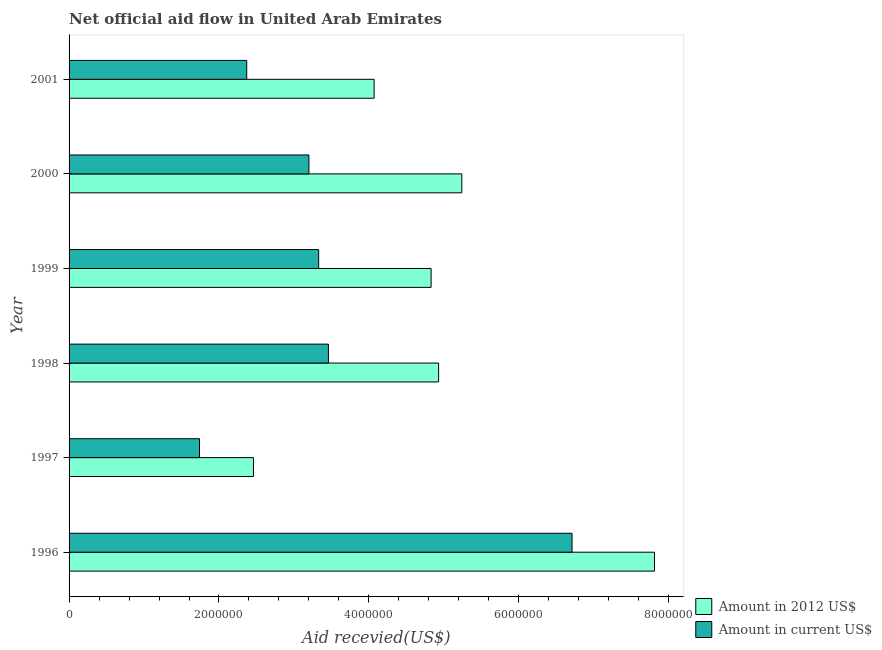How many different coloured bars are there?
Your answer should be compact. 2. How many groups of bars are there?
Your response must be concise. 6. Are the number of bars per tick equal to the number of legend labels?
Your answer should be very brief. Yes. Are the number of bars on each tick of the Y-axis equal?
Give a very brief answer. Yes. How many bars are there on the 3rd tick from the top?
Provide a short and direct response. 2. What is the amount of aid received(expressed in 2012 us$) in 1998?
Your response must be concise. 4.93e+06. Across all years, what is the maximum amount of aid received(expressed in us$)?
Make the answer very short. 6.71e+06. Across all years, what is the minimum amount of aid received(expressed in us$)?
Your answer should be very brief. 1.74e+06. In which year was the amount of aid received(expressed in us$) minimum?
Make the answer very short. 1997. What is the total amount of aid received(expressed in 2012 us$) in the graph?
Your response must be concise. 2.93e+07. What is the difference between the amount of aid received(expressed in us$) in 1999 and that in 2000?
Your answer should be compact. 1.30e+05. What is the difference between the amount of aid received(expressed in us$) in 2000 and the amount of aid received(expressed in 2012 us$) in 1997?
Your answer should be very brief. 7.40e+05. What is the average amount of aid received(expressed in us$) per year?
Make the answer very short. 3.47e+06. In the year 1996, what is the difference between the amount of aid received(expressed in us$) and amount of aid received(expressed in 2012 us$)?
Offer a terse response. -1.10e+06. What is the ratio of the amount of aid received(expressed in 2012 us$) in 1996 to that in 2001?
Provide a succinct answer. 1.92. Is the amount of aid received(expressed in 2012 us$) in 1997 less than that in 2000?
Your answer should be very brief. Yes. Is the difference between the amount of aid received(expressed in 2012 us$) in 1997 and 2000 greater than the difference between the amount of aid received(expressed in us$) in 1997 and 2000?
Keep it short and to the point. No. What is the difference between the highest and the second highest amount of aid received(expressed in us$)?
Provide a succinct answer. 3.25e+06. What is the difference between the highest and the lowest amount of aid received(expressed in us$)?
Your response must be concise. 4.97e+06. What does the 1st bar from the top in 2000 represents?
Give a very brief answer. Amount in current US$. What does the 2nd bar from the bottom in 2001 represents?
Keep it short and to the point. Amount in current US$. How many bars are there?
Provide a succinct answer. 12. How many years are there in the graph?
Your response must be concise. 6. Are the values on the major ticks of X-axis written in scientific E-notation?
Make the answer very short. No. Does the graph contain any zero values?
Offer a very short reply. No. Does the graph contain grids?
Your answer should be compact. No. How many legend labels are there?
Your answer should be very brief. 2. What is the title of the graph?
Offer a terse response. Net official aid flow in United Arab Emirates. Does "Male entrants" appear as one of the legend labels in the graph?
Keep it short and to the point. No. What is the label or title of the X-axis?
Offer a very short reply. Aid recevied(US$). What is the label or title of the Y-axis?
Your response must be concise. Year. What is the Aid recevied(US$) of Amount in 2012 US$ in 1996?
Your response must be concise. 7.81e+06. What is the Aid recevied(US$) in Amount in current US$ in 1996?
Ensure brevity in your answer.  6.71e+06. What is the Aid recevied(US$) in Amount in 2012 US$ in 1997?
Provide a succinct answer. 2.46e+06. What is the Aid recevied(US$) in Amount in current US$ in 1997?
Give a very brief answer. 1.74e+06. What is the Aid recevied(US$) of Amount in 2012 US$ in 1998?
Provide a short and direct response. 4.93e+06. What is the Aid recevied(US$) in Amount in current US$ in 1998?
Offer a terse response. 3.46e+06. What is the Aid recevied(US$) in Amount in 2012 US$ in 1999?
Keep it short and to the point. 4.83e+06. What is the Aid recevied(US$) in Amount in current US$ in 1999?
Your answer should be compact. 3.33e+06. What is the Aid recevied(US$) in Amount in 2012 US$ in 2000?
Offer a very short reply. 5.24e+06. What is the Aid recevied(US$) of Amount in current US$ in 2000?
Keep it short and to the point. 3.20e+06. What is the Aid recevied(US$) in Amount in 2012 US$ in 2001?
Keep it short and to the point. 4.07e+06. What is the Aid recevied(US$) of Amount in current US$ in 2001?
Ensure brevity in your answer.  2.37e+06. Across all years, what is the maximum Aid recevied(US$) in Amount in 2012 US$?
Ensure brevity in your answer.  7.81e+06. Across all years, what is the maximum Aid recevied(US$) of Amount in current US$?
Your answer should be compact. 6.71e+06. Across all years, what is the minimum Aid recevied(US$) in Amount in 2012 US$?
Keep it short and to the point. 2.46e+06. Across all years, what is the minimum Aid recevied(US$) of Amount in current US$?
Make the answer very short. 1.74e+06. What is the total Aid recevied(US$) in Amount in 2012 US$ in the graph?
Keep it short and to the point. 2.93e+07. What is the total Aid recevied(US$) of Amount in current US$ in the graph?
Your response must be concise. 2.08e+07. What is the difference between the Aid recevied(US$) of Amount in 2012 US$ in 1996 and that in 1997?
Provide a short and direct response. 5.35e+06. What is the difference between the Aid recevied(US$) of Amount in current US$ in 1996 and that in 1997?
Make the answer very short. 4.97e+06. What is the difference between the Aid recevied(US$) in Amount in 2012 US$ in 1996 and that in 1998?
Give a very brief answer. 2.88e+06. What is the difference between the Aid recevied(US$) of Amount in current US$ in 1996 and that in 1998?
Your response must be concise. 3.25e+06. What is the difference between the Aid recevied(US$) of Amount in 2012 US$ in 1996 and that in 1999?
Your response must be concise. 2.98e+06. What is the difference between the Aid recevied(US$) in Amount in current US$ in 1996 and that in 1999?
Provide a succinct answer. 3.38e+06. What is the difference between the Aid recevied(US$) of Amount in 2012 US$ in 1996 and that in 2000?
Provide a short and direct response. 2.57e+06. What is the difference between the Aid recevied(US$) in Amount in current US$ in 1996 and that in 2000?
Your answer should be very brief. 3.51e+06. What is the difference between the Aid recevied(US$) in Amount in 2012 US$ in 1996 and that in 2001?
Give a very brief answer. 3.74e+06. What is the difference between the Aid recevied(US$) of Amount in current US$ in 1996 and that in 2001?
Offer a very short reply. 4.34e+06. What is the difference between the Aid recevied(US$) of Amount in 2012 US$ in 1997 and that in 1998?
Give a very brief answer. -2.47e+06. What is the difference between the Aid recevied(US$) in Amount in current US$ in 1997 and that in 1998?
Your answer should be compact. -1.72e+06. What is the difference between the Aid recevied(US$) of Amount in 2012 US$ in 1997 and that in 1999?
Offer a terse response. -2.37e+06. What is the difference between the Aid recevied(US$) in Amount in current US$ in 1997 and that in 1999?
Your response must be concise. -1.59e+06. What is the difference between the Aid recevied(US$) of Amount in 2012 US$ in 1997 and that in 2000?
Make the answer very short. -2.78e+06. What is the difference between the Aid recevied(US$) in Amount in current US$ in 1997 and that in 2000?
Provide a succinct answer. -1.46e+06. What is the difference between the Aid recevied(US$) of Amount in 2012 US$ in 1997 and that in 2001?
Your answer should be very brief. -1.61e+06. What is the difference between the Aid recevied(US$) in Amount in current US$ in 1997 and that in 2001?
Offer a very short reply. -6.30e+05. What is the difference between the Aid recevied(US$) of Amount in 2012 US$ in 1998 and that in 2000?
Your answer should be compact. -3.10e+05. What is the difference between the Aid recevied(US$) in Amount in 2012 US$ in 1998 and that in 2001?
Your answer should be very brief. 8.60e+05. What is the difference between the Aid recevied(US$) of Amount in current US$ in 1998 and that in 2001?
Ensure brevity in your answer.  1.09e+06. What is the difference between the Aid recevied(US$) of Amount in 2012 US$ in 1999 and that in 2000?
Offer a terse response. -4.10e+05. What is the difference between the Aid recevied(US$) of Amount in 2012 US$ in 1999 and that in 2001?
Your response must be concise. 7.60e+05. What is the difference between the Aid recevied(US$) of Amount in current US$ in 1999 and that in 2001?
Your answer should be very brief. 9.60e+05. What is the difference between the Aid recevied(US$) in Amount in 2012 US$ in 2000 and that in 2001?
Ensure brevity in your answer.  1.17e+06. What is the difference between the Aid recevied(US$) in Amount in current US$ in 2000 and that in 2001?
Keep it short and to the point. 8.30e+05. What is the difference between the Aid recevied(US$) of Amount in 2012 US$ in 1996 and the Aid recevied(US$) of Amount in current US$ in 1997?
Your response must be concise. 6.07e+06. What is the difference between the Aid recevied(US$) in Amount in 2012 US$ in 1996 and the Aid recevied(US$) in Amount in current US$ in 1998?
Your response must be concise. 4.35e+06. What is the difference between the Aid recevied(US$) in Amount in 2012 US$ in 1996 and the Aid recevied(US$) in Amount in current US$ in 1999?
Keep it short and to the point. 4.48e+06. What is the difference between the Aid recevied(US$) of Amount in 2012 US$ in 1996 and the Aid recevied(US$) of Amount in current US$ in 2000?
Give a very brief answer. 4.61e+06. What is the difference between the Aid recevied(US$) in Amount in 2012 US$ in 1996 and the Aid recevied(US$) in Amount in current US$ in 2001?
Give a very brief answer. 5.44e+06. What is the difference between the Aid recevied(US$) of Amount in 2012 US$ in 1997 and the Aid recevied(US$) of Amount in current US$ in 1998?
Ensure brevity in your answer.  -1.00e+06. What is the difference between the Aid recevied(US$) of Amount in 2012 US$ in 1997 and the Aid recevied(US$) of Amount in current US$ in 1999?
Offer a terse response. -8.70e+05. What is the difference between the Aid recevied(US$) of Amount in 2012 US$ in 1997 and the Aid recevied(US$) of Amount in current US$ in 2000?
Provide a short and direct response. -7.40e+05. What is the difference between the Aid recevied(US$) in Amount in 2012 US$ in 1997 and the Aid recevied(US$) in Amount in current US$ in 2001?
Keep it short and to the point. 9.00e+04. What is the difference between the Aid recevied(US$) of Amount in 2012 US$ in 1998 and the Aid recevied(US$) of Amount in current US$ in 1999?
Ensure brevity in your answer.  1.60e+06. What is the difference between the Aid recevied(US$) of Amount in 2012 US$ in 1998 and the Aid recevied(US$) of Amount in current US$ in 2000?
Make the answer very short. 1.73e+06. What is the difference between the Aid recevied(US$) of Amount in 2012 US$ in 1998 and the Aid recevied(US$) of Amount in current US$ in 2001?
Your answer should be compact. 2.56e+06. What is the difference between the Aid recevied(US$) of Amount in 2012 US$ in 1999 and the Aid recevied(US$) of Amount in current US$ in 2000?
Ensure brevity in your answer.  1.63e+06. What is the difference between the Aid recevied(US$) in Amount in 2012 US$ in 1999 and the Aid recevied(US$) in Amount in current US$ in 2001?
Offer a terse response. 2.46e+06. What is the difference between the Aid recevied(US$) of Amount in 2012 US$ in 2000 and the Aid recevied(US$) of Amount in current US$ in 2001?
Your answer should be very brief. 2.87e+06. What is the average Aid recevied(US$) of Amount in 2012 US$ per year?
Give a very brief answer. 4.89e+06. What is the average Aid recevied(US$) of Amount in current US$ per year?
Give a very brief answer. 3.47e+06. In the year 1996, what is the difference between the Aid recevied(US$) of Amount in 2012 US$ and Aid recevied(US$) of Amount in current US$?
Your response must be concise. 1.10e+06. In the year 1997, what is the difference between the Aid recevied(US$) of Amount in 2012 US$ and Aid recevied(US$) of Amount in current US$?
Your answer should be very brief. 7.20e+05. In the year 1998, what is the difference between the Aid recevied(US$) in Amount in 2012 US$ and Aid recevied(US$) in Amount in current US$?
Give a very brief answer. 1.47e+06. In the year 1999, what is the difference between the Aid recevied(US$) in Amount in 2012 US$ and Aid recevied(US$) in Amount in current US$?
Your answer should be very brief. 1.50e+06. In the year 2000, what is the difference between the Aid recevied(US$) of Amount in 2012 US$ and Aid recevied(US$) of Amount in current US$?
Your answer should be compact. 2.04e+06. In the year 2001, what is the difference between the Aid recevied(US$) of Amount in 2012 US$ and Aid recevied(US$) of Amount in current US$?
Provide a succinct answer. 1.70e+06. What is the ratio of the Aid recevied(US$) in Amount in 2012 US$ in 1996 to that in 1997?
Give a very brief answer. 3.17. What is the ratio of the Aid recevied(US$) of Amount in current US$ in 1996 to that in 1997?
Provide a succinct answer. 3.86. What is the ratio of the Aid recevied(US$) of Amount in 2012 US$ in 1996 to that in 1998?
Give a very brief answer. 1.58. What is the ratio of the Aid recevied(US$) of Amount in current US$ in 1996 to that in 1998?
Your answer should be compact. 1.94. What is the ratio of the Aid recevied(US$) in Amount in 2012 US$ in 1996 to that in 1999?
Make the answer very short. 1.62. What is the ratio of the Aid recevied(US$) of Amount in current US$ in 1996 to that in 1999?
Offer a terse response. 2.02. What is the ratio of the Aid recevied(US$) of Amount in 2012 US$ in 1996 to that in 2000?
Your answer should be compact. 1.49. What is the ratio of the Aid recevied(US$) in Amount in current US$ in 1996 to that in 2000?
Make the answer very short. 2.1. What is the ratio of the Aid recevied(US$) in Amount in 2012 US$ in 1996 to that in 2001?
Your answer should be very brief. 1.92. What is the ratio of the Aid recevied(US$) in Amount in current US$ in 1996 to that in 2001?
Your response must be concise. 2.83. What is the ratio of the Aid recevied(US$) of Amount in 2012 US$ in 1997 to that in 1998?
Provide a succinct answer. 0.5. What is the ratio of the Aid recevied(US$) in Amount in current US$ in 1997 to that in 1998?
Your answer should be compact. 0.5. What is the ratio of the Aid recevied(US$) in Amount in 2012 US$ in 1997 to that in 1999?
Your answer should be compact. 0.51. What is the ratio of the Aid recevied(US$) of Amount in current US$ in 1997 to that in 1999?
Your answer should be compact. 0.52. What is the ratio of the Aid recevied(US$) of Amount in 2012 US$ in 1997 to that in 2000?
Offer a terse response. 0.47. What is the ratio of the Aid recevied(US$) of Amount in current US$ in 1997 to that in 2000?
Provide a succinct answer. 0.54. What is the ratio of the Aid recevied(US$) of Amount in 2012 US$ in 1997 to that in 2001?
Make the answer very short. 0.6. What is the ratio of the Aid recevied(US$) of Amount in current US$ in 1997 to that in 2001?
Offer a very short reply. 0.73. What is the ratio of the Aid recevied(US$) of Amount in 2012 US$ in 1998 to that in 1999?
Your answer should be compact. 1.02. What is the ratio of the Aid recevied(US$) of Amount in current US$ in 1998 to that in 1999?
Your answer should be very brief. 1.04. What is the ratio of the Aid recevied(US$) of Amount in 2012 US$ in 1998 to that in 2000?
Keep it short and to the point. 0.94. What is the ratio of the Aid recevied(US$) in Amount in current US$ in 1998 to that in 2000?
Provide a succinct answer. 1.08. What is the ratio of the Aid recevied(US$) in Amount in 2012 US$ in 1998 to that in 2001?
Offer a very short reply. 1.21. What is the ratio of the Aid recevied(US$) in Amount in current US$ in 1998 to that in 2001?
Give a very brief answer. 1.46. What is the ratio of the Aid recevied(US$) in Amount in 2012 US$ in 1999 to that in 2000?
Make the answer very short. 0.92. What is the ratio of the Aid recevied(US$) in Amount in current US$ in 1999 to that in 2000?
Give a very brief answer. 1.04. What is the ratio of the Aid recevied(US$) of Amount in 2012 US$ in 1999 to that in 2001?
Offer a terse response. 1.19. What is the ratio of the Aid recevied(US$) of Amount in current US$ in 1999 to that in 2001?
Your answer should be very brief. 1.41. What is the ratio of the Aid recevied(US$) in Amount in 2012 US$ in 2000 to that in 2001?
Provide a short and direct response. 1.29. What is the ratio of the Aid recevied(US$) in Amount in current US$ in 2000 to that in 2001?
Provide a succinct answer. 1.35. What is the difference between the highest and the second highest Aid recevied(US$) in Amount in 2012 US$?
Offer a terse response. 2.57e+06. What is the difference between the highest and the second highest Aid recevied(US$) in Amount in current US$?
Your answer should be compact. 3.25e+06. What is the difference between the highest and the lowest Aid recevied(US$) of Amount in 2012 US$?
Make the answer very short. 5.35e+06. What is the difference between the highest and the lowest Aid recevied(US$) in Amount in current US$?
Provide a short and direct response. 4.97e+06. 